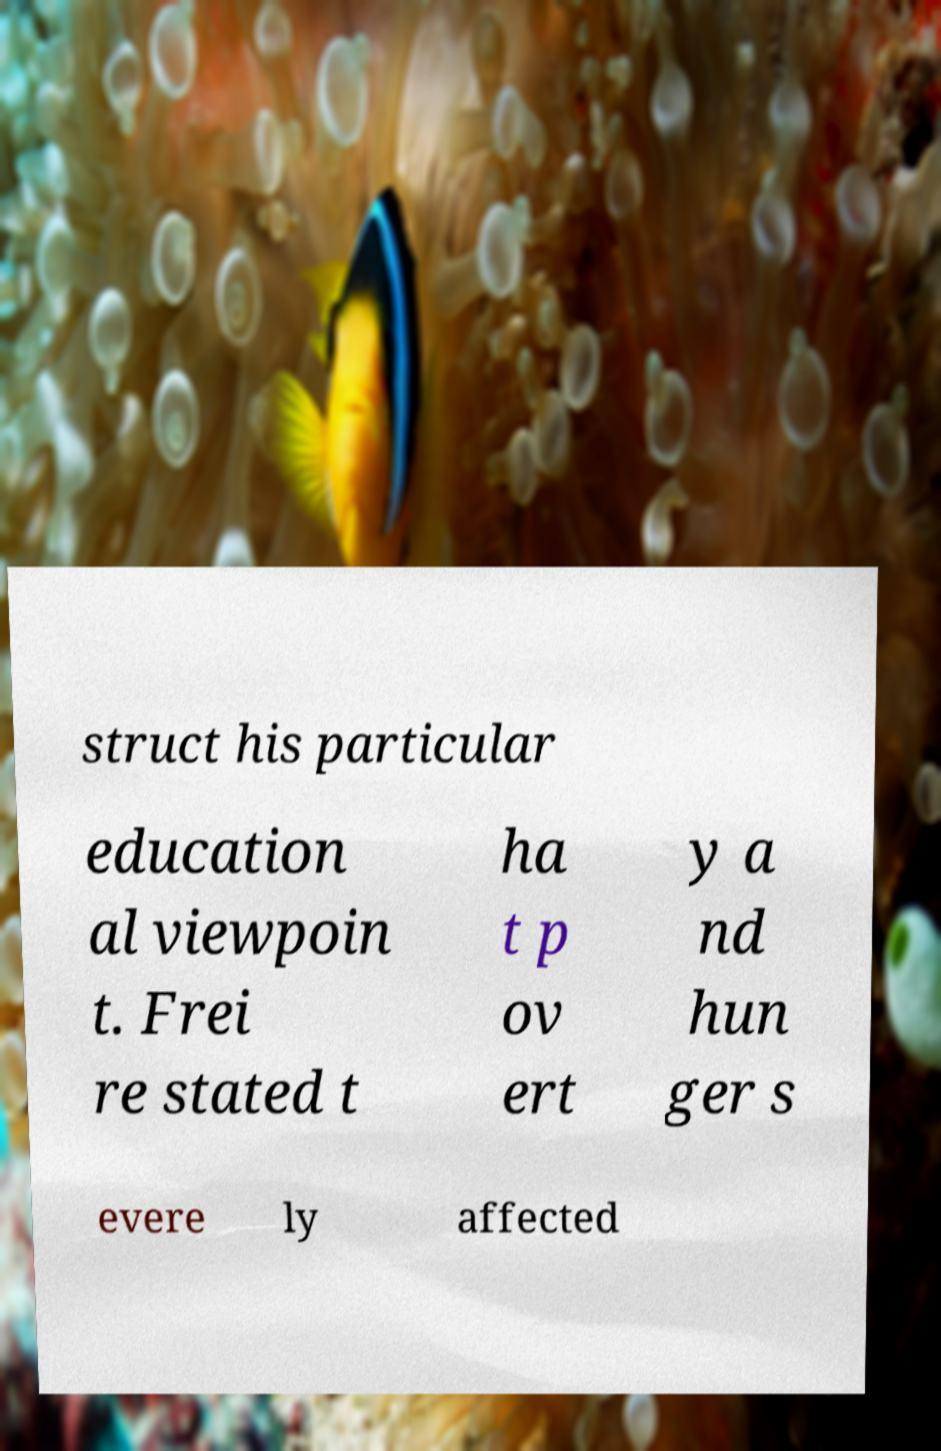Can you read and provide the text displayed in the image?This photo seems to have some interesting text. Can you extract and type it out for me? struct his particular education al viewpoin t. Frei re stated t ha t p ov ert y a nd hun ger s evere ly affected 